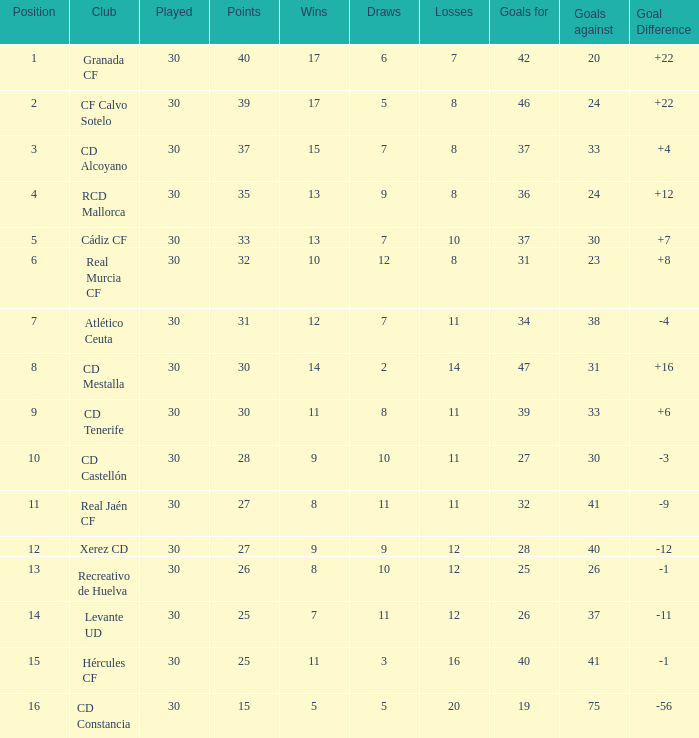How many Wins have Goals against smaller than 30, and Goals for larger than 25, and Draws larger than 5? 3.0. 